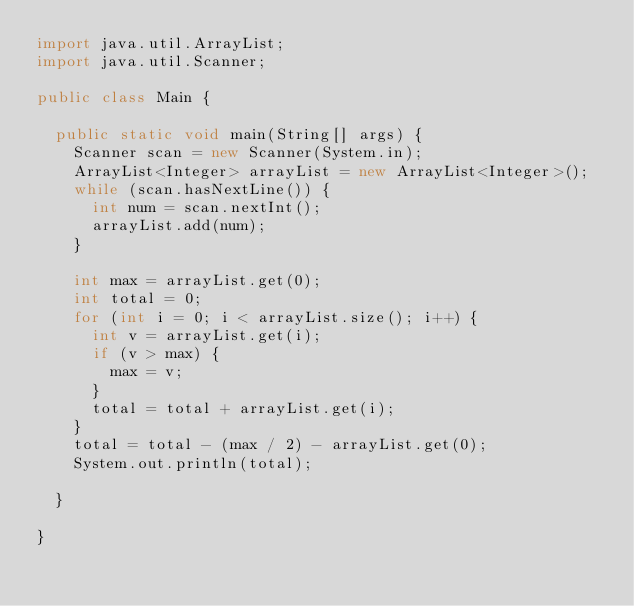Convert code to text. <code><loc_0><loc_0><loc_500><loc_500><_Java_>import java.util.ArrayList;
import java.util.Scanner;

public class Main {

	public static void main(String[] args) {
		Scanner scan = new Scanner(System.in);
		ArrayList<Integer> arrayList = new ArrayList<Integer>();
		while (scan.hasNextLine()) {
			int num = scan.nextInt();
			arrayList.add(num);
		}

		int max = arrayList.get(0);
		int total = 0;
		for (int i = 0; i < arrayList.size(); i++) {
			int v = arrayList.get(i);
			if (v > max) {
				max = v;
			}
			total = total + arrayList.get(i);
		}
		total = total - (max / 2) - arrayList.get(0);
		System.out.println(total);

	}

}
</code> 